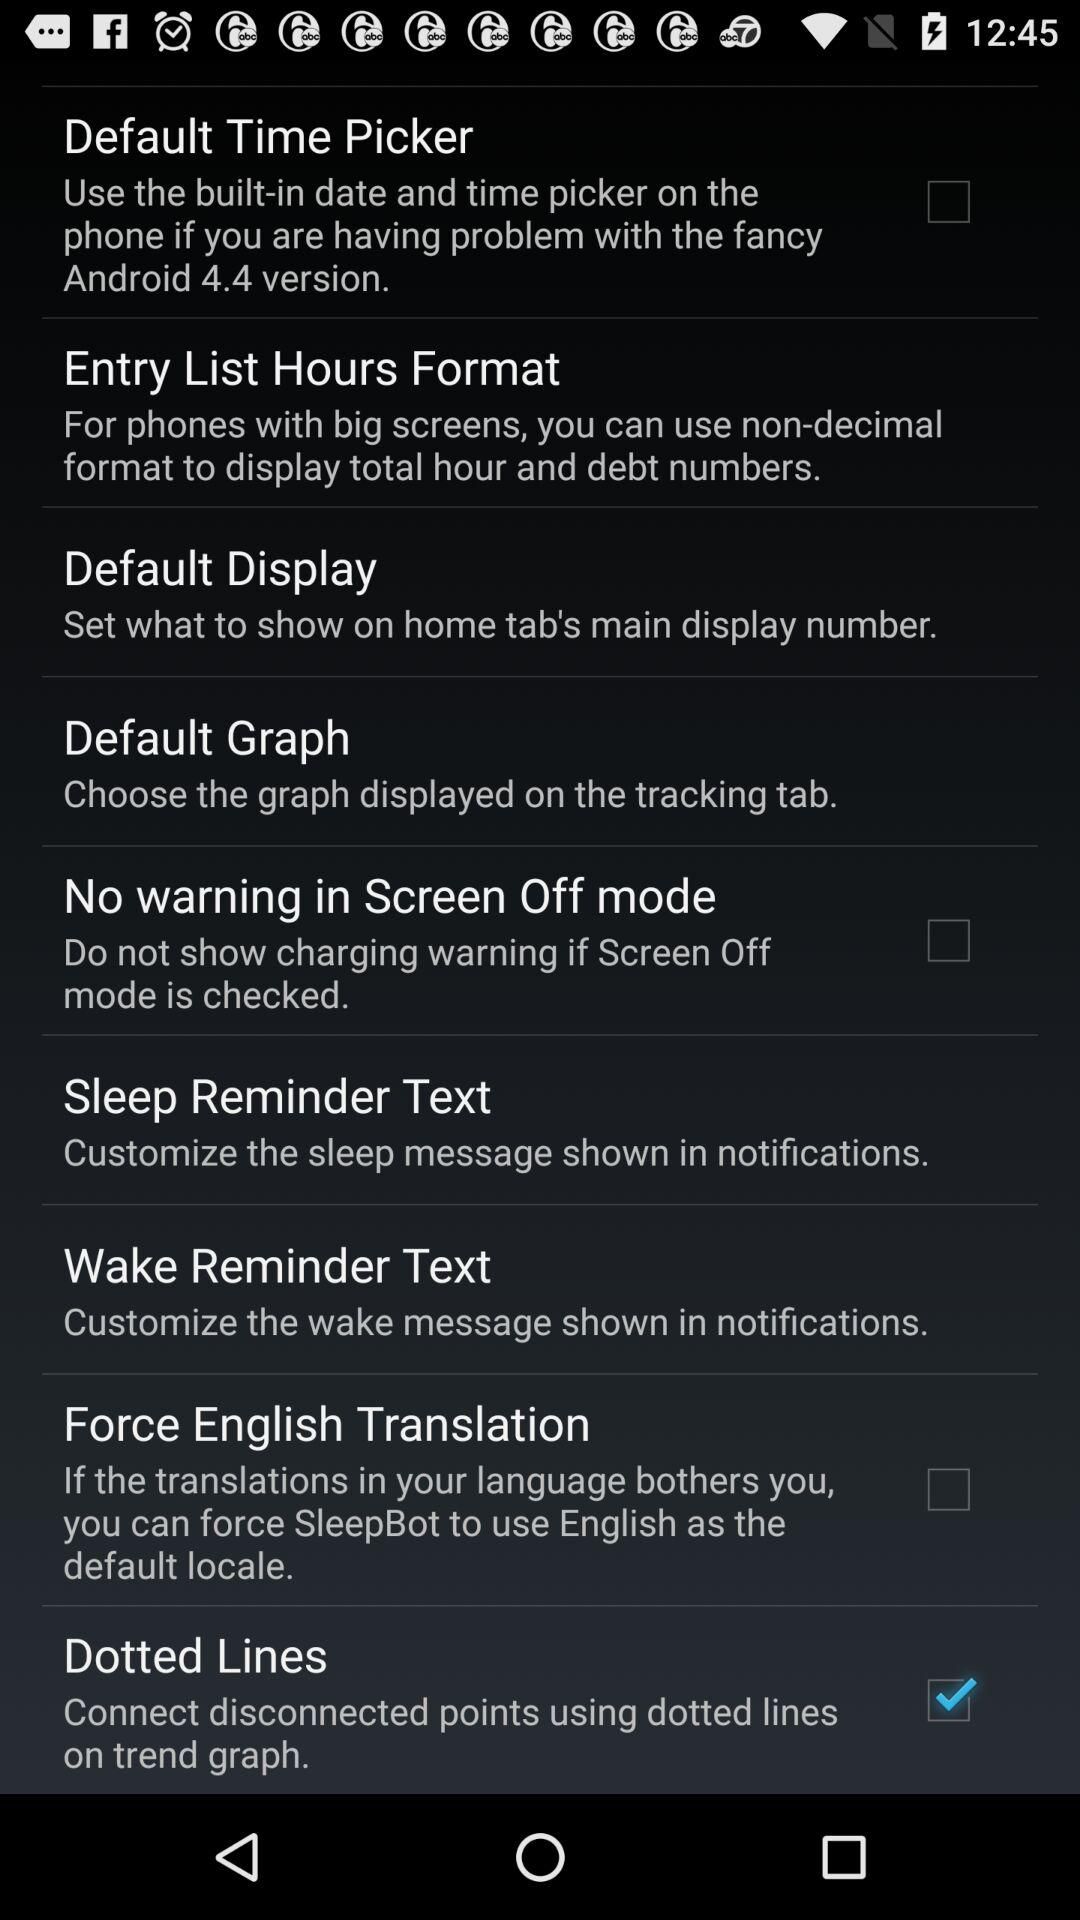What is the purpose of the "Sleep Reminder Text" setting? The purpose of the "Sleep Reminder Text" setting is to "Customize the sleep message shown in notifications.". 